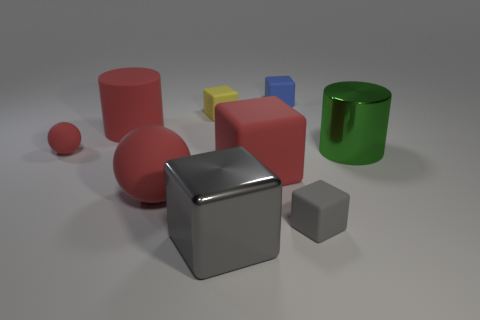How many small red rubber things are to the right of the tiny matte block in front of the big cylinder behind the green metallic object?
Keep it short and to the point. 0. Are there any other large metallic cylinders of the same color as the big shiny cylinder?
Offer a very short reply. No. There is a sphere that is the same size as the yellow matte object; what is its color?
Offer a terse response. Red. There is a big red matte thing on the right side of the big metallic object that is left of the small rubber block that is in front of the large green thing; what shape is it?
Provide a succinct answer. Cube. There is a cylinder behind the large green cylinder; how many tiny blocks are left of it?
Keep it short and to the point. 0. Do the big red object behind the big green cylinder and the large red rubber object on the right side of the big red ball have the same shape?
Keep it short and to the point. No. What number of small matte cubes are right of the small yellow rubber cube?
Your answer should be compact. 2. Is the tiny block that is in front of the large red ball made of the same material as the blue object?
Offer a very short reply. Yes. There is a metal object that is the same shape as the small gray rubber thing; what is its color?
Ensure brevity in your answer.  Gray. What shape is the tiny red matte thing?
Offer a very short reply. Sphere. 